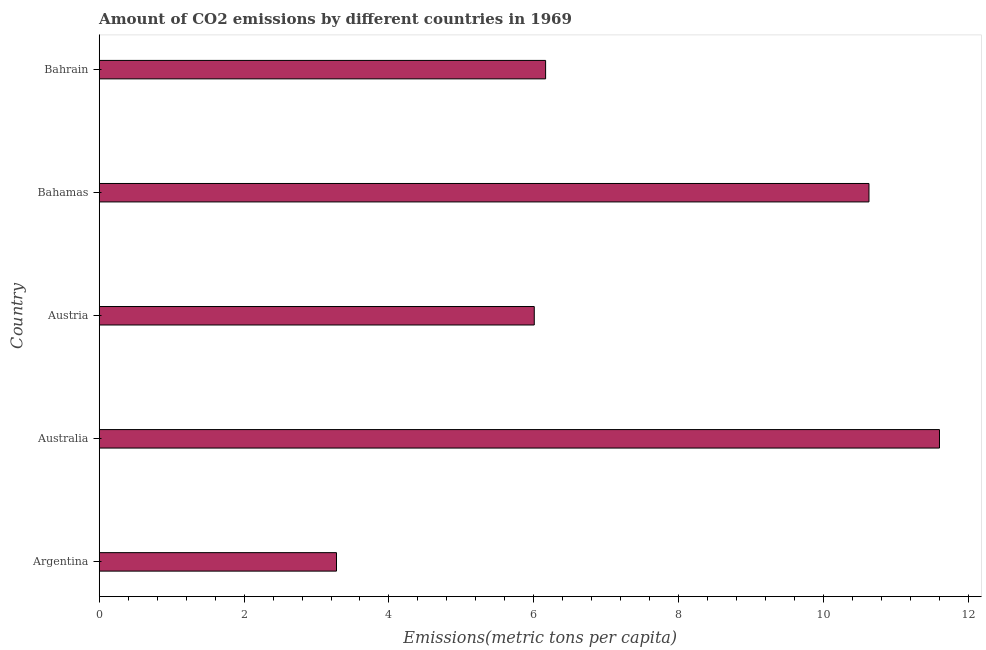Does the graph contain any zero values?
Your answer should be compact. No. Does the graph contain grids?
Ensure brevity in your answer.  No. What is the title of the graph?
Keep it short and to the point. Amount of CO2 emissions by different countries in 1969. What is the label or title of the X-axis?
Provide a succinct answer. Emissions(metric tons per capita). What is the amount of co2 emissions in Bahrain?
Ensure brevity in your answer.  6.16. Across all countries, what is the maximum amount of co2 emissions?
Provide a succinct answer. 11.6. Across all countries, what is the minimum amount of co2 emissions?
Keep it short and to the point. 3.28. In which country was the amount of co2 emissions maximum?
Keep it short and to the point. Australia. What is the sum of the amount of co2 emissions?
Provide a succinct answer. 37.67. What is the difference between the amount of co2 emissions in Austria and Bahrain?
Your response must be concise. -0.16. What is the average amount of co2 emissions per country?
Offer a terse response. 7.54. What is the median amount of co2 emissions?
Your response must be concise. 6.16. In how many countries, is the amount of co2 emissions greater than 7.6 metric tons per capita?
Your answer should be compact. 2. What is the ratio of the amount of co2 emissions in Australia to that in Bahrain?
Your response must be concise. 1.88. Is the amount of co2 emissions in Argentina less than that in Bahrain?
Give a very brief answer. Yes. Is the difference between the amount of co2 emissions in Austria and Bahrain greater than the difference between any two countries?
Provide a short and direct response. No. What is the difference between the highest and the lowest amount of co2 emissions?
Ensure brevity in your answer.  8.32. How many bars are there?
Make the answer very short. 5. How many countries are there in the graph?
Keep it short and to the point. 5. What is the Emissions(metric tons per capita) in Argentina?
Offer a very short reply. 3.28. What is the Emissions(metric tons per capita) of Australia?
Make the answer very short. 11.6. What is the Emissions(metric tons per capita) in Austria?
Offer a terse response. 6.01. What is the Emissions(metric tons per capita) in Bahamas?
Offer a very short reply. 10.63. What is the Emissions(metric tons per capita) of Bahrain?
Give a very brief answer. 6.16. What is the difference between the Emissions(metric tons per capita) in Argentina and Australia?
Give a very brief answer. -8.32. What is the difference between the Emissions(metric tons per capita) in Argentina and Austria?
Your response must be concise. -2.73. What is the difference between the Emissions(metric tons per capita) in Argentina and Bahamas?
Make the answer very short. -7.35. What is the difference between the Emissions(metric tons per capita) in Argentina and Bahrain?
Offer a terse response. -2.89. What is the difference between the Emissions(metric tons per capita) in Australia and Austria?
Provide a short and direct response. 5.59. What is the difference between the Emissions(metric tons per capita) in Australia and Bahamas?
Provide a succinct answer. 0.97. What is the difference between the Emissions(metric tons per capita) in Australia and Bahrain?
Your answer should be very brief. 5.44. What is the difference between the Emissions(metric tons per capita) in Austria and Bahamas?
Provide a succinct answer. -4.62. What is the difference between the Emissions(metric tons per capita) in Austria and Bahrain?
Keep it short and to the point. -0.16. What is the difference between the Emissions(metric tons per capita) in Bahamas and Bahrain?
Ensure brevity in your answer.  4.46. What is the ratio of the Emissions(metric tons per capita) in Argentina to that in Australia?
Your answer should be compact. 0.28. What is the ratio of the Emissions(metric tons per capita) in Argentina to that in Austria?
Keep it short and to the point. 0.55. What is the ratio of the Emissions(metric tons per capita) in Argentina to that in Bahamas?
Make the answer very short. 0.31. What is the ratio of the Emissions(metric tons per capita) in Argentina to that in Bahrain?
Make the answer very short. 0.53. What is the ratio of the Emissions(metric tons per capita) in Australia to that in Austria?
Your answer should be compact. 1.93. What is the ratio of the Emissions(metric tons per capita) in Australia to that in Bahamas?
Give a very brief answer. 1.09. What is the ratio of the Emissions(metric tons per capita) in Australia to that in Bahrain?
Offer a very short reply. 1.88. What is the ratio of the Emissions(metric tons per capita) in Austria to that in Bahamas?
Offer a very short reply. 0.56. What is the ratio of the Emissions(metric tons per capita) in Austria to that in Bahrain?
Your response must be concise. 0.97. What is the ratio of the Emissions(metric tons per capita) in Bahamas to that in Bahrain?
Your answer should be compact. 1.72. 